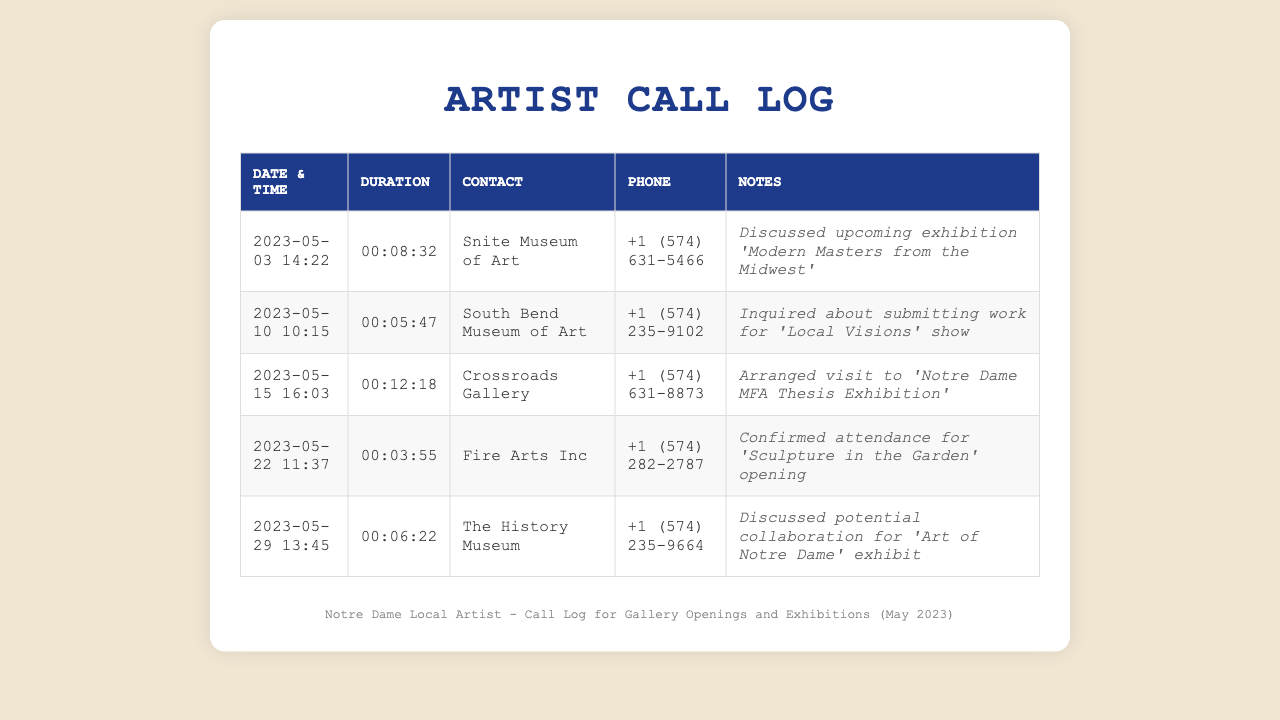what is the date and time of the call to South Bend Museum of Art? The date and time of the call can be found in the first column of the corresponding row for South Bend Museum of Art.
Answer: 2023-05-10 10:15 how long was the call made to Crossroads Gallery? The duration of the call is provided in the second column of the row for Crossroads Gallery.
Answer: 00:12:18 who was the contact for the discussion about 'Modern Masters from the Midwest'? The contact's name can be found in the third column of the row that refers to the discussion about 'Modern Masters from the Midwest'.
Answer: Snite Museum of Art which call had the shortest duration? This can be determined by comparing the values in the duration column to find the shortest one.
Answer: 00:03:55 what was discussed during the call with The History Museum? The discussion topic is reflected in the notes column of the row corresponding to The History Museum.
Answer: potential collaboration for 'Art of Notre Dame' exhibit how many calls were made in total according to the log? The total number of rows in the document indicates the total number of calls made.
Answer: 5 who has the phone number +1 (574) 631-5466? The phone number is listed in the row for the corresponding contact, which identifies the affiliated organization.
Answer: Snite Museum of Art what is the last date in the call log? The last date can be found by examining the date column for the most recent entry.
Answer: 2023-05-29 